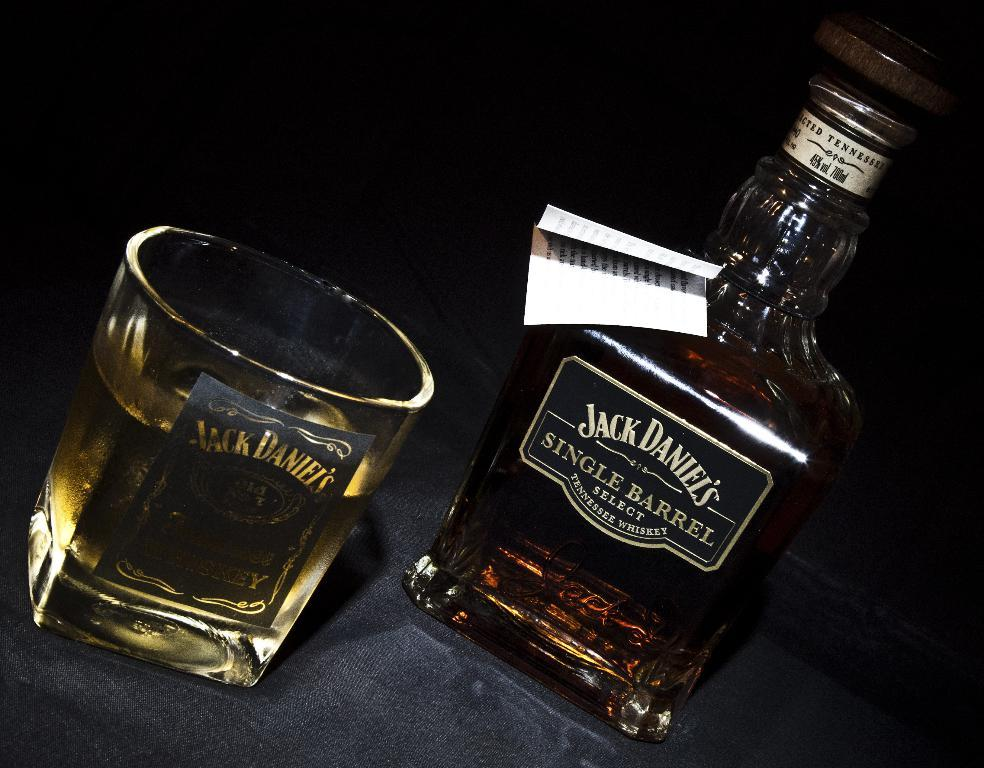<image>
Describe the image concisely. A bottle of Jack Daniels whiskey on a table next to a glass filled with the liquor. 